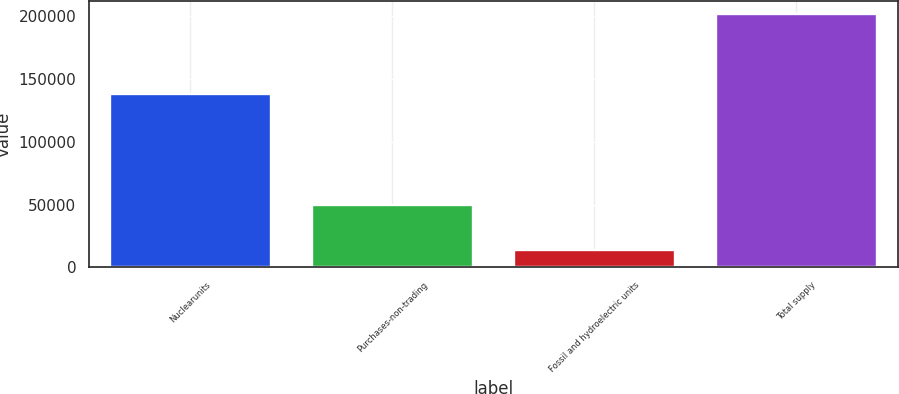Convert chart. <chart><loc_0><loc_0><loc_500><loc_500><bar_chart><fcel>Nuclearunits<fcel>Purchases-non-trading<fcel>Fossil and hydroelectric units<fcel>Total supply<nl><fcel>137832<fcel>50098<fcel>13891<fcel>201821<nl></chart> 